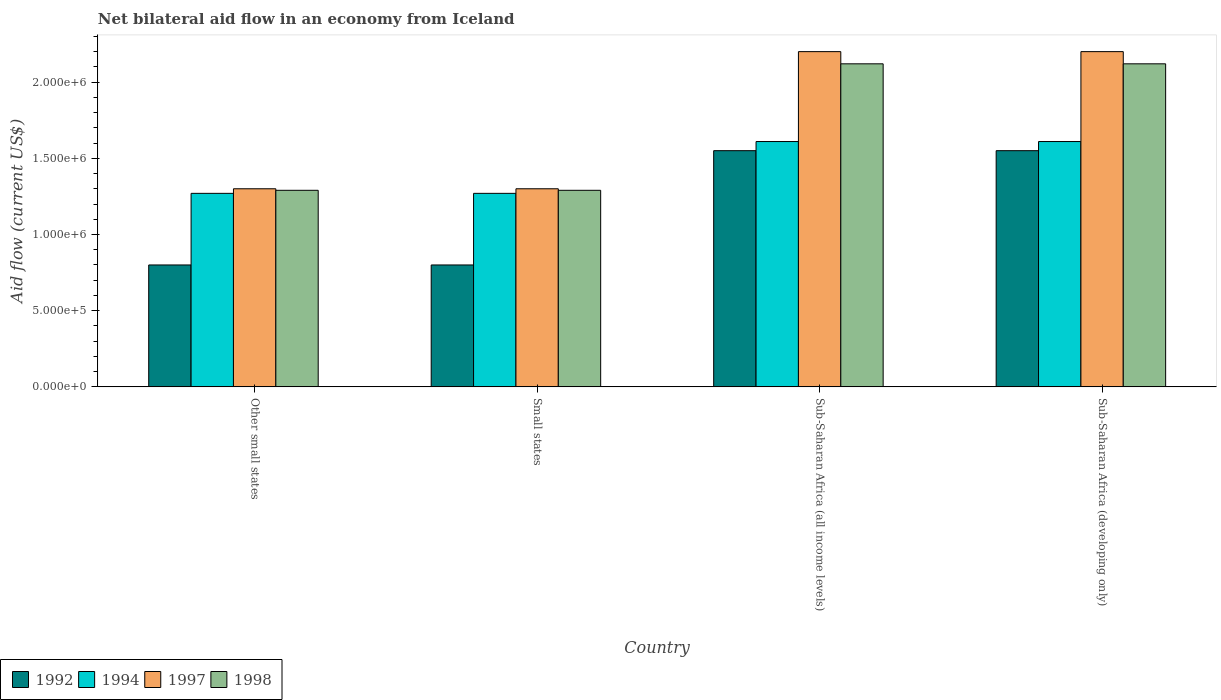How many bars are there on the 2nd tick from the left?
Your answer should be compact. 4. How many bars are there on the 3rd tick from the right?
Your response must be concise. 4. What is the label of the 4th group of bars from the left?
Your answer should be very brief. Sub-Saharan Africa (developing only). In how many cases, is the number of bars for a given country not equal to the number of legend labels?
Offer a very short reply. 0. What is the net bilateral aid flow in 1997 in Sub-Saharan Africa (all income levels)?
Offer a terse response. 2.20e+06. Across all countries, what is the maximum net bilateral aid flow in 1992?
Offer a very short reply. 1.55e+06. In which country was the net bilateral aid flow in 1994 maximum?
Offer a very short reply. Sub-Saharan Africa (all income levels). In which country was the net bilateral aid flow in 1998 minimum?
Your response must be concise. Other small states. What is the total net bilateral aid flow in 1992 in the graph?
Make the answer very short. 4.70e+06. What is the difference between the net bilateral aid flow in 1992 in Sub-Saharan Africa (developing only) and the net bilateral aid flow in 1998 in Sub-Saharan Africa (all income levels)?
Your response must be concise. -5.70e+05. What is the average net bilateral aid flow in 1992 per country?
Ensure brevity in your answer.  1.18e+06. In how many countries, is the net bilateral aid flow in 1998 greater than 1100000 US$?
Ensure brevity in your answer.  4. What is the ratio of the net bilateral aid flow in 1997 in Other small states to that in Sub-Saharan Africa (all income levels)?
Make the answer very short. 0.59. In how many countries, is the net bilateral aid flow in 1994 greater than the average net bilateral aid flow in 1994 taken over all countries?
Your response must be concise. 2. What does the 4th bar from the right in Sub-Saharan Africa (developing only) represents?
Give a very brief answer. 1992. Is it the case that in every country, the sum of the net bilateral aid flow in 1994 and net bilateral aid flow in 1998 is greater than the net bilateral aid flow in 1997?
Provide a short and direct response. Yes. How many bars are there?
Offer a very short reply. 16. Are all the bars in the graph horizontal?
Ensure brevity in your answer.  No. How many countries are there in the graph?
Keep it short and to the point. 4. Are the values on the major ticks of Y-axis written in scientific E-notation?
Offer a very short reply. Yes. Does the graph contain grids?
Keep it short and to the point. No. How many legend labels are there?
Provide a succinct answer. 4. What is the title of the graph?
Your response must be concise. Net bilateral aid flow in an economy from Iceland. Does "2005" appear as one of the legend labels in the graph?
Give a very brief answer. No. What is the label or title of the X-axis?
Your answer should be very brief. Country. What is the label or title of the Y-axis?
Ensure brevity in your answer.  Aid flow (current US$). What is the Aid flow (current US$) of 1994 in Other small states?
Keep it short and to the point. 1.27e+06. What is the Aid flow (current US$) of 1997 in Other small states?
Your answer should be very brief. 1.30e+06. What is the Aid flow (current US$) in 1998 in Other small states?
Your answer should be compact. 1.29e+06. What is the Aid flow (current US$) in 1994 in Small states?
Offer a terse response. 1.27e+06. What is the Aid flow (current US$) in 1997 in Small states?
Offer a very short reply. 1.30e+06. What is the Aid flow (current US$) in 1998 in Small states?
Your answer should be very brief. 1.29e+06. What is the Aid flow (current US$) in 1992 in Sub-Saharan Africa (all income levels)?
Provide a short and direct response. 1.55e+06. What is the Aid flow (current US$) of 1994 in Sub-Saharan Africa (all income levels)?
Give a very brief answer. 1.61e+06. What is the Aid flow (current US$) in 1997 in Sub-Saharan Africa (all income levels)?
Ensure brevity in your answer.  2.20e+06. What is the Aid flow (current US$) in 1998 in Sub-Saharan Africa (all income levels)?
Provide a short and direct response. 2.12e+06. What is the Aid flow (current US$) in 1992 in Sub-Saharan Africa (developing only)?
Ensure brevity in your answer.  1.55e+06. What is the Aid flow (current US$) of 1994 in Sub-Saharan Africa (developing only)?
Provide a short and direct response. 1.61e+06. What is the Aid flow (current US$) in 1997 in Sub-Saharan Africa (developing only)?
Offer a terse response. 2.20e+06. What is the Aid flow (current US$) in 1998 in Sub-Saharan Africa (developing only)?
Ensure brevity in your answer.  2.12e+06. Across all countries, what is the maximum Aid flow (current US$) of 1992?
Offer a terse response. 1.55e+06. Across all countries, what is the maximum Aid flow (current US$) of 1994?
Give a very brief answer. 1.61e+06. Across all countries, what is the maximum Aid flow (current US$) of 1997?
Provide a short and direct response. 2.20e+06. Across all countries, what is the maximum Aid flow (current US$) of 1998?
Provide a succinct answer. 2.12e+06. Across all countries, what is the minimum Aid flow (current US$) of 1992?
Keep it short and to the point. 8.00e+05. Across all countries, what is the minimum Aid flow (current US$) in 1994?
Provide a succinct answer. 1.27e+06. Across all countries, what is the minimum Aid flow (current US$) of 1997?
Offer a very short reply. 1.30e+06. Across all countries, what is the minimum Aid flow (current US$) in 1998?
Provide a succinct answer. 1.29e+06. What is the total Aid flow (current US$) of 1992 in the graph?
Ensure brevity in your answer.  4.70e+06. What is the total Aid flow (current US$) of 1994 in the graph?
Make the answer very short. 5.76e+06. What is the total Aid flow (current US$) of 1998 in the graph?
Provide a short and direct response. 6.82e+06. What is the difference between the Aid flow (current US$) in 1994 in Other small states and that in Small states?
Keep it short and to the point. 0. What is the difference between the Aid flow (current US$) of 1997 in Other small states and that in Small states?
Your answer should be compact. 0. What is the difference between the Aid flow (current US$) in 1992 in Other small states and that in Sub-Saharan Africa (all income levels)?
Provide a short and direct response. -7.50e+05. What is the difference between the Aid flow (current US$) of 1997 in Other small states and that in Sub-Saharan Africa (all income levels)?
Make the answer very short. -9.00e+05. What is the difference between the Aid flow (current US$) of 1998 in Other small states and that in Sub-Saharan Africa (all income levels)?
Make the answer very short. -8.30e+05. What is the difference between the Aid flow (current US$) of 1992 in Other small states and that in Sub-Saharan Africa (developing only)?
Offer a terse response. -7.50e+05. What is the difference between the Aid flow (current US$) of 1994 in Other small states and that in Sub-Saharan Africa (developing only)?
Keep it short and to the point. -3.40e+05. What is the difference between the Aid flow (current US$) in 1997 in Other small states and that in Sub-Saharan Africa (developing only)?
Give a very brief answer. -9.00e+05. What is the difference between the Aid flow (current US$) in 1998 in Other small states and that in Sub-Saharan Africa (developing only)?
Provide a short and direct response. -8.30e+05. What is the difference between the Aid flow (current US$) of 1992 in Small states and that in Sub-Saharan Africa (all income levels)?
Offer a terse response. -7.50e+05. What is the difference between the Aid flow (current US$) in 1994 in Small states and that in Sub-Saharan Africa (all income levels)?
Your response must be concise. -3.40e+05. What is the difference between the Aid flow (current US$) in 1997 in Small states and that in Sub-Saharan Africa (all income levels)?
Make the answer very short. -9.00e+05. What is the difference between the Aid flow (current US$) of 1998 in Small states and that in Sub-Saharan Africa (all income levels)?
Make the answer very short. -8.30e+05. What is the difference between the Aid flow (current US$) of 1992 in Small states and that in Sub-Saharan Africa (developing only)?
Provide a succinct answer. -7.50e+05. What is the difference between the Aid flow (current US$) of 1997 in Small states and that in Sub-Saharan Africa (developing only)?
Offer a terse response. -9.00e+05. What is the difference between the Aid flow (current US$) of 1998 in Small states and that in Sub-Saharan Africa (developing only)?
Ensure brevity in your answer.  -8.30e+05. What is the difference between the Aid flow (current US$) of 1992 in Sub-Saharan Africa (all income levels) and that in Sub-Saharan Africa (developing only)?
Offer a very short reply. 0. What is the difference between the Aid flow (current US$) of 1997 in Sub-Saharan Africa (all income levels) and that in Sub-Saharan Africa (developing only)?
Your answer should be compact. 0. What is the difference between the Aid flow (current US$) of 1992 in Other small states and the Aid flow (current US$) of 1994 in Small states?
Provide a succinct answer. -4.70e+05. What is the difference between the Aid flow (current US$) in 1992 in Other small states and the Aid flow (current US$) in 1997 in Small states?
Provide a succinct answer. -5.00e+05. What is the difference between the Aid flow (current US$) of 1992 in Other small states and the Aid flow (current US$) of 1998 in Small states?
Ensure brevity in your answer.  -4.90e+05. What is the difference between the Aid flow (current US$) in 1994 in Other small states and the Aid flow (current US$) in 1997 in Small states?
Provide a succinct answer. -3.00e+04. What is the difference between the Aid flow (current US$) in 1997 in Other small states and the Aid flow (current US$) in 1998 in Small states?
Keep it short and to the point. 10000. What is the difference between the Aid flow (current US$) in 1992 in Other small states and the Aid flow (current US$) in 1994 in Sub-Saharan Africa (all income levels)?
Keep it short and to the point. -8.10e+05. What is the difference between the Aid flow (current US$) of 1992 in Other small states and the Aid flow (current US$) of 1997 in Sub-Saharan Africa (all income levels)?
Make the answer very short. -1.40e+06. What is the difference between the Aid flow (current US$) in 1992 in Other small states and the Aid flow (current US$) in 1998 in Sub-Saharan Africa (all income levels)?
Offer a terse response. -1.32e+06. What is the difference between the Aid flow (current US$) in 1994 in Other small states and the Aid flow (current US$) in 1997 in Sub-Saharan Africa (all income levels)?
Provide a short and direct response. -9.30e+05. What is the difference between the Aid flow (current US$) of 1994 in Other small states and the Aid flow (current US$) of 1998 in Sub-Saharan Africa (all income levels)?
Keep it short and to the point. -8.50e+05. What is the difference between the Aid flow (current US$) of 1997 in Other small states and the Aid flow (current US$) of 1998 in Sub-Saharan Africa (all income levels)?
Your answer should be very brief. -8.20e+05. What is the difference between the Aid flow (current US$) in 1992 in Other small states and the Aid flow (current US$) in 1994 in Sub-Saharan Africa (developing only)?
Give a very brief answer. -8.10e+05. What is the difference between the Aid flow (current US$) of 1992 in Other small states and the Aid flow (current US$) of 1997 in Sub-Saharan Africa (developing only)?
Ensure brevity in your answer.  -1.40e+06. What is the difference between the Aid flow (current US$) in 1992 in Other small states and the Aid flow (current US$) in 1998 in Sub-Saharan Africa (developing only)?
Provide a succinct answer. -1.32e+06. What is the difference between the Aid flow (current US$) of 1994 in Other small states and the Aid flow (current US$) of 1997 in Sub-Saharan Africa (developing only)?
Offer a very short reply. -9.30e+05. What is the difference between the Aid flow (current US$) of 1994 in Other small states and the Aid flow (current US$) of 1998 in Sub-Saharan Africa (developing only)?
Provide a short and direct response. -8.50e+05. What is the difference between the Aid flow (current US$) of 1997 in Other small states and the Aid flow (current US$) of 1998 in Sub-Saharan Africa (developing only)?
Offer a terse response. -8.20e+05. What is the difference between the Aid flow (current US$) of 1992 in Small states and the Aid flow (current US$) of 1994 in Sub-Saharan Africa (all income levels)?
Make the answer very short. -8.10e+05. What is the difference between the Aid flow (current US$) of 1992 in Small states and the Aid flow (current US$) of 1997 in Sub-Saharan Africa (all income levels)?
Provide a short and direct response. -1.40e+06. What is the difference between the Aid flow (current US$) in 1992 in Small states and the Aid flow (current US$) in 1998 in Sub-Saharan Africa (all income levels)?
Your response must be concise. -1.32e+06. What is the difference between the Aid flow (current US$) of 1994 in Small states and the Aid flow (current US$) of 1997 in Sub-Saharan Africa (all income levels)?
Offer a very short reply. -9.30e+05. What is the difference between the Aid flow (current US$) in 1994 in Small states and the Aid flow (current US$) in 1998 in Sub-Saharan Africa (all income levels)?
Give a very brief answer. -8.50e+05. What is the difference between the Aid flow (current US$) in 1997 in Small states and the Aid flow (current US$) in 1998 in Sub-Saharan Africa (all income levels)?
Offer a terse response. -8.20e+05. What is the difference between the Aid flow (current US$) of 1992 in Small states and the Aid flow (current US$) of 1994 in Sub-Saharan Africa (developing only)?
Ensure brevity in your answer.  -8.10e+05. What is the difference between the Aid flow (current US$) in 1992 in Small states and the Aid flow (current US$) in 1997 in Sub-Saharan Africa (developing only)?
Make the answer very short. -1.40e+06. What is the difference between the Aid flow (current US$) in 1992 in Small states and the Aid flow (current US$) in 1998 in Sub-Saharan Africa (developing only)?
Your answer should be very brief. -1.32e+06. What is the difference between the Aid flow (current US$) in 1994 in Small states and the Aid flow (current US$) in 1997 in Sub-Saharan Africa (developing only)?
Offer a terse response. -9.30e+05. What is the difference between the Aid flow (current US$) in 1994 in Small states and the Aid flow (current US$) in 1998 in Sub-Saharan Africa (developing only)?
Your answer should be compact. -8.50e+05. What is the difference between the Aid flow (current US$) of 1997 in Small states and the Aid flow (current US$) of 1998 in Sub-Saharan Africa (developing only)?
Give a very brief answer. -8.20e+05. What is the difference between the Aid flow (current US$) of 1992 in Sub-Saharan Africa (all income levels) and the Aid flow (current US$) of 1997 in Sub-Saharan Africa (developing only)?
Your response must be concise. -6.50e+05. What is the difference between the Aid flow (current US$) of 1992 in Sub-Saharan Africa (all income levels) and the Aid flow (current US$) of 1998 in Sub-Saharan Africa (developing only)?
Your answer should be very brief. -5.70e+05. What is the difference between the Aid flow (current US$) in 1994 in Sub-Saharan Africa (all income levels) and the Aid flow (current US$) in 1997 in Sub-Saharan Africa (developing only)?
Ensure brevity in your answer.  -5.90e+05. What is the difference between the Aid flow (current US$) of 1994 in Sub-Saharan Africa (all income levels) and the Aid flow (current US$) of 1998 in Sub-Saharan Africa (developing only)?
Give a very brief answer. -5.10e+05. What is the average Aid flow (current US$) of 1992 per country?
Give a very brief answer. 1.18e+06. What is the average Aid flow (current US$) in 1994 per country?
Offer a terse response. 1.44e+06. What is the average Aid flow (current US$) of 1997 per country?
Offer a terse response. 1.75e+06. What is the average Aid flow (current US$) of 1998 per country?
Your response must be concise. 1.70e+06. What is the difference between the Aid flow (current US$) in 1992 and Aid flow (current US$) in 1994 in Other small states?
Ensure brevity in your answer.  -4.70e+05. What is the difference between the Aid flow (current US$) in 1992 and Aid flow (current US$) in 1997 in Other small states?
Give a very brief answer. -5.00e+05. What is the difference between the Aid flow (current US$) in 1992 and Aid flow (current US$) in 1998 in Other small states?
Your response must be concise. -4.90e+05. What is the difference between the Aid flow (current US$) of 1994 and Aid flow (current US$) of 1998 in Other small states?
Offer a very short reply. -2.00e+04. What is the difference between the Aid flow (current US$) of 1992 and Aid flow (current US$) of 1994 in Small states?
Ensure brevity in your answer.  -4.70e+05. What is the difference between the Aid flow (current US$) of 1992 and Aid flow (current US$) of 1997 in Small states?
Your answer should be very brief. -5.00e+05. What is the difference between the Aid flow (current US$) in 1992 and Aid flow (current US$) in 1998 in Small states?
Make the answer very short. -4.90e+05. What is the difference between the Aid flow (current US$) of 1994 and Aid flow (current US$) of 1997 in Small states?
Give a very brief answer. -3.00e+04. What is the difference between the Aid flow (current US$) in 1992 and Aid flow (current US$) in 1997 in Sub-Saharan Africa (all income levels)?
Provide a short and direct response. -6.50e+05. What is the difference between the Aid flow (current US$) in 1992 and Aid flow (current US$) in 1998 in Sub-Saharan Africa (all income levels)?
Offer a terse response. -5.70e+05. What is the difference between the Aid flow (current US$) of 1994 and Aid flow (current US$) of 1997 in Sub-Saharan Africa (all income levels)?
Make the answer very short. -5.90e+05. What is the difference between the Aid flow (current US$) of 1994 and Aid flow (current US$) of 1998 in Sub-Saharan Africa (all income levels)?
Ensure brevity in your answer.  -5.10e+05. What is the difference between the Aid flow (current US$) of 1997 and Aid flow (current US$) of 1998 in Sub-Saharan Africa (all income levels)?
Ensure brevity in your answer.  8.00e+04. What is the difference between the Aid flow (current US$) of 1992 and Aid flow (current US$) of 1994 in Sub-Saharan Africa (developing only)?
Ensure brevity in your answer.  -6.00e+04. What is the difference between the Aid flow (current US$) of 1992 and Aid flow (current US$) of 1997 in Sub-Saharan Africa (developing only)?
Offer a terse response. -6.50e+05. What is the difference between the Aid flow (current US$) of 1992 and Aid flow (current US$) of 1998 in Sub-Saharan Africa (developing only)?
Keep it short and to the point. -5.70e+05. What is the difference between the Aid flow (current US$) in 1994 and Aid flow (current US$) in 1997 in Sub-Saharan Africa (developing only)?
Provide a short and direct response. -5.90e+05. What is the difference between the Aid flow (current US$) in 1994 and Aid flow (current US$) in 1998 in Sub-Saharan Africa (developing only)?
Make the answer very short. -5.10e+05. What is the ratio of the Aid flow (current US$) of 1992 in Other small states to that in Small states?
Make the answer very short. 1. What is the ratio of the Aid flow (current US$) of 1994 in Other small states to that in Small states?
Give a very brief answer. 1. What is the ratio of the Aid flow (current US$) of 1997 in Other small states to that in Small states?
Your answer should be very brief. 1. What is the ratio of the Aid flow (current US$) in 1992 in Other small states to that in Sub-Saharan Africa (all income levels)?
Provide a succinct answer. 0.52. What is the ratio of the Aid flow (current US$) of 1994 in Other small states to that in Sub-Saharan Africa (all income levels)?
Ensure brevity in your answer.  0.79. What is the ratio of the Aid flow (current US$) in 1997 in Other small states to that in Sub-Saharan Africa (all income levels)?
Offer a very short reply. 0.59. What is the ratio of the Aid flow (current US$) of 1998 in Other small states to that in Sub-Saharan Africa (all income levels)?
Your response must be concise. 0.61. What is the ratio of the Aid flow (current US$) of 1992 in Other small states to that in Sub-Saharan Africa (developing only)?
Give a very brief answer. 0.52. What is the ratio of the Aid flow (current US$) of 1994 in Other small states to that in Sub-Saharan Africa (developing only)?
Your response must be concise. 0.79. What is the ratio of the Aid flow (current US$) in 1997 in Other small states to that in Sub-Saharan Africa (developing only)?
Your answer should be very brief. 0.59. What is the ratio of the Aid flow (current US$) in 1998 in Other small states to that in Sub-Saharan Africa (developing only)?
Ensure brevity in your answer.  0.61. What is the ratio of the Aid flow (current US$) of 1992 in Small states to that in Sub-Saharan Africa (all income levels)?
Your answer should be compact. 0.52. What is the ratio of the Aid flow (current US$) in 1994 in Small states to that in Sub-Saharan Africa (all income levels)?
Your answer should be compact. 0.79. What is the ratio of the Aid flow (current US$) in 1997 in Small states to that in Sub-Saharan Africa (all income levels)?
Provide a succinct answer. 0.59. What is the ratio of the Aid flow (current US$) in 1998 in Small states to that in Sub-Saharan Africa (all income levels)?
Ensure brevity in your answer.  0.61. What is the ratio of the Aid flow (current US$) in 1992 in Small states to that in Sub-Saharan Africa (developing only)?
Your answer should be compact. 0.52. What is the ratio of the Aid flow (current US$) in 1994 in Small states to that in Sub-Saharan Africa (developing only)?
Your answer should be very brief. 0.79. What is the ratio of the Aid flow (current US$) of 1997 in Small states to that in Sub-Saharan Africa (developing only)?
Your answer should be very brief. 0.59. What is the ratio of the Aid flow (current US$) in 1998 in Small states to that in Sub-Saharan Africa (developing only)?
Give a very brief answer. 0.61. What is the ratio of the Aid flow (current US$) in 1997 in Sub-Saharan Africa (all income levels) to that in Sub-Saharan Africa (developing only)?
Keep it short and to the point. 1. What is the ratio of the Aid flow (current US$) in 1998 in Sub-Saharan Africa (all income levels) to that in Sub-Saharan Africa (developing only)?
Provide a succinct answer. 1. What is the difference between the highest and the second highest Aid flow (current US$) of 1994?
Your answer should be very brief. 0. What is the difference between the highest and the second highest Aid flow (current US$) in 1998?
Your response must be concise. 0. What is the difference between the highest and the lowest Aid flow (current US$) in 1992?
Your response must be concise. 7.50e+05. What is the difference between the highest and the lowest Aid flow (current US$) in 1994?
Your answer should be compact. 3.40e+05. What is the difference between the highest and the lowest Aid flow (current US$) in 1997?
Keep it short and to the point. 9.00e+05. What is the difference between the highest and the lowest Aid flow (current US$) of 1998?
Your answer should be compact. 8.30e+05. 